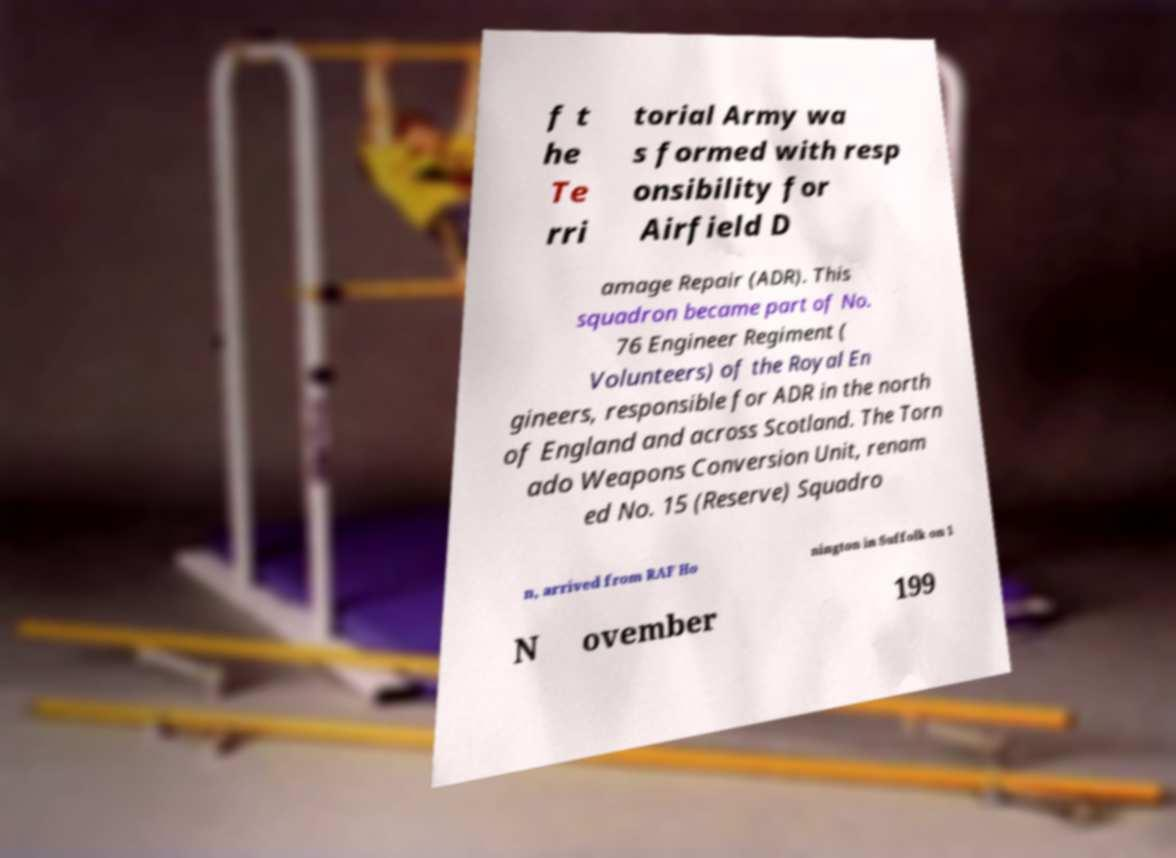What messages or text are displayed in this image? I need them in a readable, typed format. f t he Te rri torial Army wa s formed with resp onsibility for Airfield D amage Repair (ADR). This squadron became part of No. 76 Engineer Regiment ( Volunteers) of the Royal En gineers, responsible for ADR in the north of England and across Scotland. The Torn ado Weapons Conversion Unit, renam ed No. 15 (Reserve) Squadro n, arrived from RAF Ho nington in Suffolk on 1 N ovember 199 